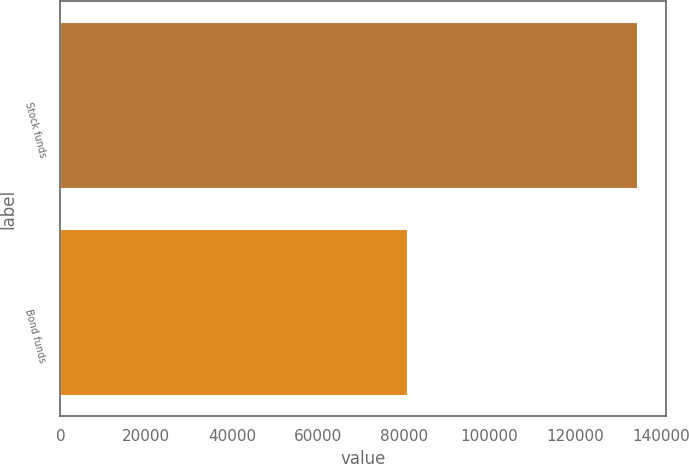Convert chart to OTSL. <chart><loc_0><loc_0><loc_500><loc_500><bar_chart><fcel>Stock funds<fcel>Bond funds<nl><fcel>134445<fcel>80714<nl></chart> 